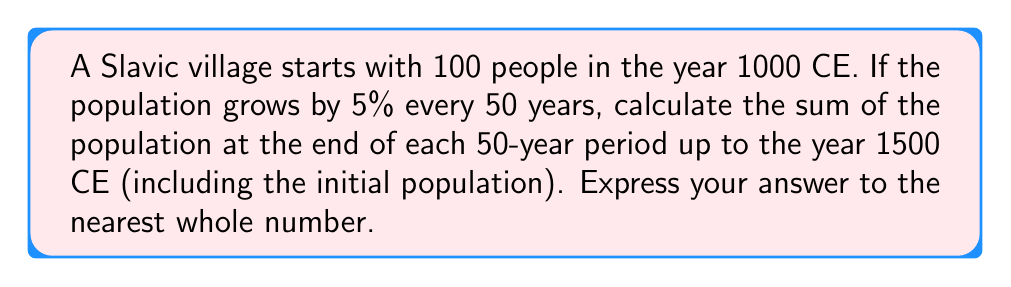Teach me how to tackle this problem. Let's approach this step-by-step:

1) First, we need to identify the components of our geometric sequence:
   - Initial term (a): 100
   - Common ratio (r): 1.05 (5% increase = 1 + 0.05 = 1.05)
   - Number of terms (n): 11 (from 1000 CE to 1500 CE, there are 10 intervals of 50 years, plus the initial population)

2) The formula for the sum of a geometric sequence is:
   $$S_n = \frac{a(1-r^n)}{1-r}$$
   where $S_n$ is the sum, $a$ is the first term, $r$ is the common ratio, and $n$ is the number of terms.

3) Let's substitute our values:
   $$S_{11} = \frac{100(1-1.05^{11})}{1-1.05}$$

4) Calculate $1.05^{11}$:
   $$1.05^{11} \approx 1.7101$$

5) Now our equation looks like:
   $$S_{11} = \frac{100(1-1.7101)}{1-1.05} = \frac{100(-0.7101)}{-0.05}$$

6) Simplify:
   $$S_{11} = \frac{71.01}{0.05} = 1420.2$$

7) Rounding to the nearest whole number:
   $$S_{11} \approx 1420$$
Answer: 1420 